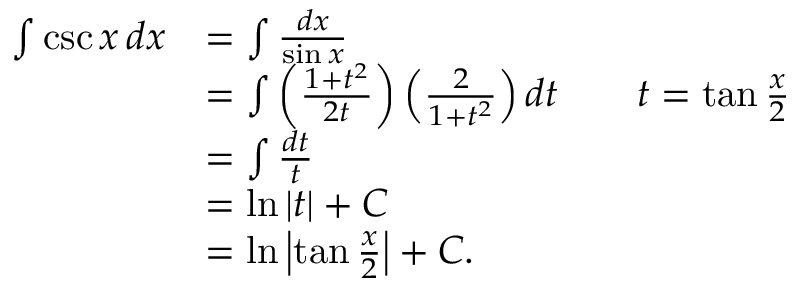<formula> <loc_0><loc_0><loc_500><loc_500>{ \begin{array} { r l r l } { \int \csc x \, d x } & { = \int { \frac { d x } { \sin x } } } \\ & { = \int \left ( { \frac { 1 + t ^ { 2 } } { 2 t } } \right ) \left ( { \frac { 2 } { 1 + t ^ { 2 } } } \right ) d t } & & { t = \tan { \frac { x } { 2 } } } \\ & { = \int { \frac { d t } { t } } } \\ & { = \ln | t | + C } \\ & { = \ln \left | \tan { \frac { x } { 2 } } \right | + C . } \end{array} }</formula> 